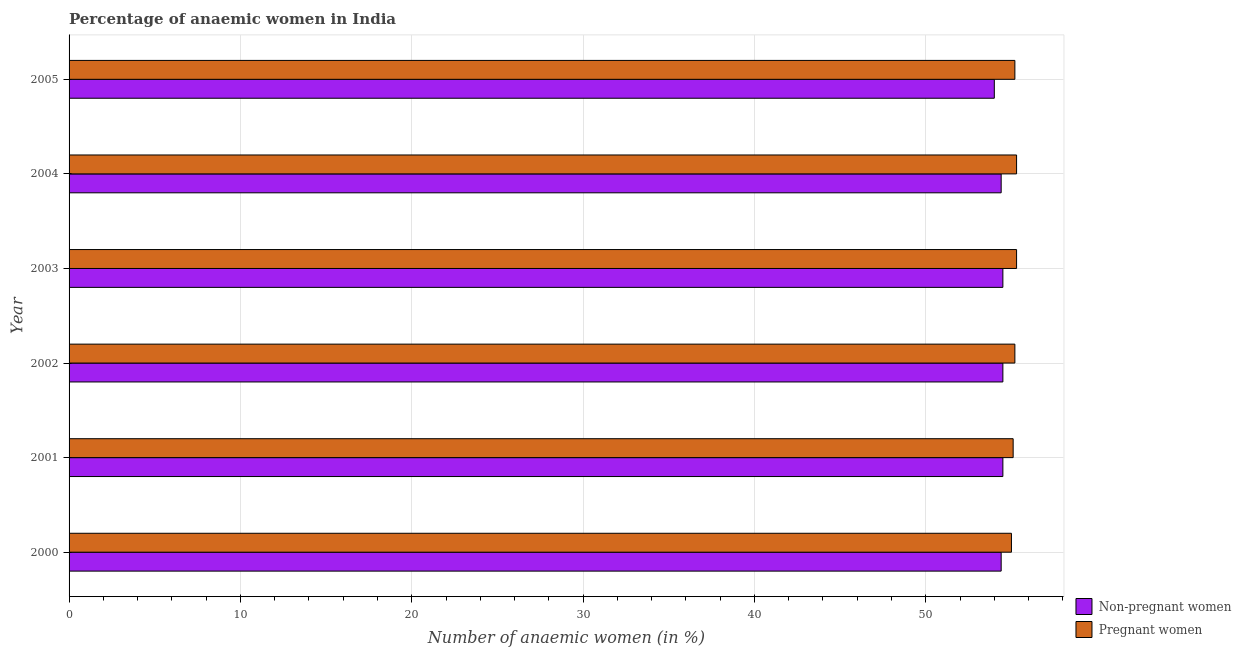How many groups of bars are there?
Keep it short and to the point. 6. Are the number of bars on each tick of the Y-axis equal?
Provide a short and direct response. Yes. How many bars are there on the 2nd tick from the top?
Provide a short and direct response. 2. How many bars are there on the 4th tick from the bottom?
Your response must be concise. 2. What is the percentage of pregnant anaemic women in 2004?
Your answer should be very brief. 55.3. Across all years, what is the maximum percentage of pregnant anaemic women?
Ensure brevity in your answer.  55.3. In which year was the percentage of non-pregnant anaemic women maximum?
Your response must be concise. 2001. In which year was the percentage of non-pregnant anaemic women minimum?
Keep it short and to the point. 2005. What is the total percentage of non-pregnant anaemic women in the graph?
Offer a terse response. 326.3. What is the difference between the percentage of non-pregnant anaemic women in 2000 and that in 2005?
Offer a very short reply. 0.4. What is the difference between the percentage of non-pregnant anaemic women in 2004 and the percentage of pregnant anaemic women in 2002?
Your response must be concise. -0.8. What is the average percentage of non-pregnant anaemic women per year?
Offer a very short reply. 54.38. In the year 2000, what is the difference between the percentage of non-pregnant anaemic women and percentage of pregnant anaemic women?
Make the answer very short. -0.6. What is the ratio of the percentage of pregnant anaemic women in 2000 to that in 2003?
Provide a short and direct response. 0.99. What is the difference between the highest and the lowest percentage of non-pregnant anaemic women?
Offer a very short reply. 0.5. Is the sum of the percentage of pregnant anaemic women in 2001 and 2003 greater than the maximum percentage of non-pregnant anaemic women across all years?
Provide a succinct answer. Yes. What does the 2nd bar from the top in 2005 represents?
Make the answer very short. Non-pregnant women. What does the 1st bar from the bottom in 2005 represents?
Provide a succinct answer. Non-pregnant women. How many bars are there?
Your answer should be compact. 12. What is the difference between two consecutive major ticks on the X-axis?
Provide a succinct answer. 10. Does the graph contain grids?
Provide a succinct answer. Yes. Where does the legend appear in the graph?
Your answer should be very brief. Bottom right. How many legend labels are there?
Ensure brevity in your answer.  2. How are the legend labels stacked?
Ensure brevity in your answer.  Vertical. What is the title of the graph?
Ensure brevity in your answer.  Percentage of anaemic women in India. What is the label or title of the X-axis?
Give a very brief answer. Number of anaemic women (in %). What is the label or title of the Y-axis?
Your answer should be very brief. Year. What is the Number of anaemic women (in %) in Non-pregnant women in 2000?
Give a very brief answer. 54.4. What is the Number of anaemic women (in %) in Non-pregnant women in 2001?
Your response must be concise. 54.5. What is the Number of anaemic women (in %) of Pregnant women in 2001?
Provide a succinct answer. 55.1. What is the Number of anaemic women (in %) of Non-pregnant women in 2002?
Ensure brevity in your answer.  54.5. What is the Number of anaemic women (in %) in Pregnant women in 2002?
Offer a terse response. 55.2. What is the Number of anaemic women (in %) of Non-pregnant women in 2003?
Ensure brevity in your answer.  54.5. What is the Number of anaemic women (in %) of Pregnant women in 2003?
Your response must be concise. 55.3. What is the Number of anaemic women (in %) in Non-pregnant women in 2004?
Offer a very short reply. 54.4. What is the Number of anaemic women (in %) of Pregnant women in 2004?
Provide a succinct answer. 55.3. What is the Number of anaemic women (in %) in Pregnant women in 2005?
Keep it short and to the point. 55.2. Across all years, what is the maximum Number of anaemic women (in %) in Non-pregnant women?
Make the answer very short. 54.5. Across all years, what is the maximum Number of anaemic women (in %) in Pregnant women?
Offer a terse response. 55.3. Across all years, what is the minimum Number of anaemic women (in %) of Non-pregnant women?
Ensure brevity in your answer.  54. Across all years, what is the minimum Number of anaemic women (in %) in Pregnant women?
Your answer should be very brief. 55. What is the total Number of anaemic women (in %) in Non-pregnant women in the graph?
Make the answer very short. 326.3. What is the total Number of anaemic women (in %) in Pregnant women in the graph?
Offer a very short reply. 331.1. What is the difference between the Number of anaemic women (in %) in Non-pregnant women in 2000 and that in 2001?
Offer a terse response. -0.1. What is the difference between the Number of anaemic women (in %) in Non-pregnant women in 2000 and that in 2002?
Your response must be concise. -0.1. What is the difference between the Number of anaemic women (in %) in Pregnant women in 2000 and that in 2002?
Offer a very short reply. -0.2. What is the difference between the Number of anaemic women (in %) of Pregnant women in 2000 and that in 2005?
Keep it short and to the point. -0.2. What is the difference between the Number of anaemic women (in %) of Non-pregnant women in 2001 and that in 2002?
Your answer should be compact. 0. What is the difference between the Number of anaemic women (in %) in Pregnant women in 2001 and that in 2002?
Give a very brief answer. -0.1. What is the difference between the Number of anaemic women (in %) in Pregnant women in 2001 and that in 2005?
Offer a terse response. -0.1. What is the difference between the Number of anaemic women (in %) in Non-pregnant women in 2002 and that in 2003?
Make the answer very short. 0. What is the difference between the Number of anaemic women (in %) of Non-pregnant women in 2002 and that in 2004?
Make the answer very short. 0.1. What is the difference between the Number of anaemic women (in %) of Non-pregnant women in 2002 and that in 2005?
Offer a terse response. 0.5. What is the difference between the Number of anaemic women (in %) of Pregnant women in 2003 and that in 2004?
Your answer should be very brief. 0. What is the difference between the Number of anaemic women (in %) in Non-pregnant women in 2003 and that in 2005?
Your answer should be compact. 0.5. What is the difference between the Number of anaemic women (in %) in Non-pregnant women in 2004 and that in 2005?
Provide a succinct answer. 0.4. What is the difference between the Number of anaemic women (in %) in Non-pregnant women in 2000 and the Number of anaemic women (in %) in Pregnant women in 2002?
Offer a terse response. -0.8. What is the difference between the Number of anaemic women (in %) in Non-pregnant women in 2002 and the Number of anaemic women (in %) in Pregnant women in 2005?
Ensure brevity in your answer.  -0.7. What is the average Number of anaemic women (in %) in Non-pregnant women per year?
Provide a short and direct response. 54.38. What is the average Number of anaemic women (in %) of Pregnant women per year?
Your answer should be compact. 55.18. In the year 2001, what is the difference between the Number of anaemic women (in %) of Non-pregnant women and Number of anaemic women (in %) of Pregnant women?
Your response must be concise. -0.6. In the year 2002, what is the difference between the Number of anaemic women (in %) in Non-pregnant women and Number of anaemic women (in %) in Pregnant women?
Keep it short and to the point. -0.7. In the year 2003, what is the difference between the Number of anaemic women (in %) in Non-pregnant women and Number of anaemic women (in %) in Pregnant women?
Provide a succinct answer. -0.8. In the year 2004, what is the difference between the Number of anaemic women (in %) in Non-pregnant women and Number of anaemic women (in %) in Pregnant women?
Make the answer very short. -0.9. What is the ratio of the Number of anaemic women (in %) of Non-pregnant women in 2000 to that in 2004?
Make the answer very short. 1. What is the ratio of the Number of anaemic women (in %) in Non-pregnant women in 2000 to that in 2005?
Offer a very short reply. 1.01. What is the ratio of the Number of anaemic women (in %) in Pregnant women in 2001 to that in 2002?
Your answer should be compact. 1. What is the ratio of the Number of anaemic women (in %) of Non-pregnant women in 2001 to that in 2003?
Provide a succinct answer. 1. What is the ratio of the Number of anaemic women (in %) of Pregnant women in 2001 to that in 2003?
Give a very brief answer. 1. What is the ratio of the Number of anaemic women (in %) of Non-pregnant women in 2001 to that in 2005?
Keep it short and to the point. 1.01. What is the ratio of the Number of anaemic women (in %) in Pregnant women in 2001 to that in 2005?
Provide a short and direct response. 1. What is the ratio of the Number of anaemic women (in %) in Pregnant women in 2002 to that in 2003?
Your answer should be compact. 1. What is the ratio of the Number of anaemic women (in %) in Non-pregnant women in 2002 to that in 2004?
Give a very brief answer. 1. What is the ratio of the Number of anaemic women (in %) of Non-pregnant women in 2002 to that in 2005?
Offer a terse response. 1.01. What is the ratio of the Number of anaemic women (in %) of Pregnant women in 2002 to that in 2005?
Your answer should be very brief. 1. What is the ratio of the Number of anaemic women (in %) of Non-pregnant women in 2003 to that in 2004?
Offer a very short reply. 1. What is the ratio of the Number of anaemic women (in %) of Non-pregnant women in 2003 to that in 2005?
Keep it short and to the point. 1.01. What is the ratio of the Number of anaemic women (in %) of Pregnant women in 2003 to that in 2005?
Your answer should be very brief. 1. What is the ratio of the Number of anaemic women (in %) of Non-pregnant women in 2004 to that in 2005?
Provide a succinct answer. 1.01. What is the ratio of the Number of anaemic women (in %) of Pregnant women in 2004 to that in 2005?
Give a very brief answer. 1. What is the difference between the highest and the lowest Number of anaemic women (in %) of Non-pregnant women?
Your answer should be compact. 0.5. 